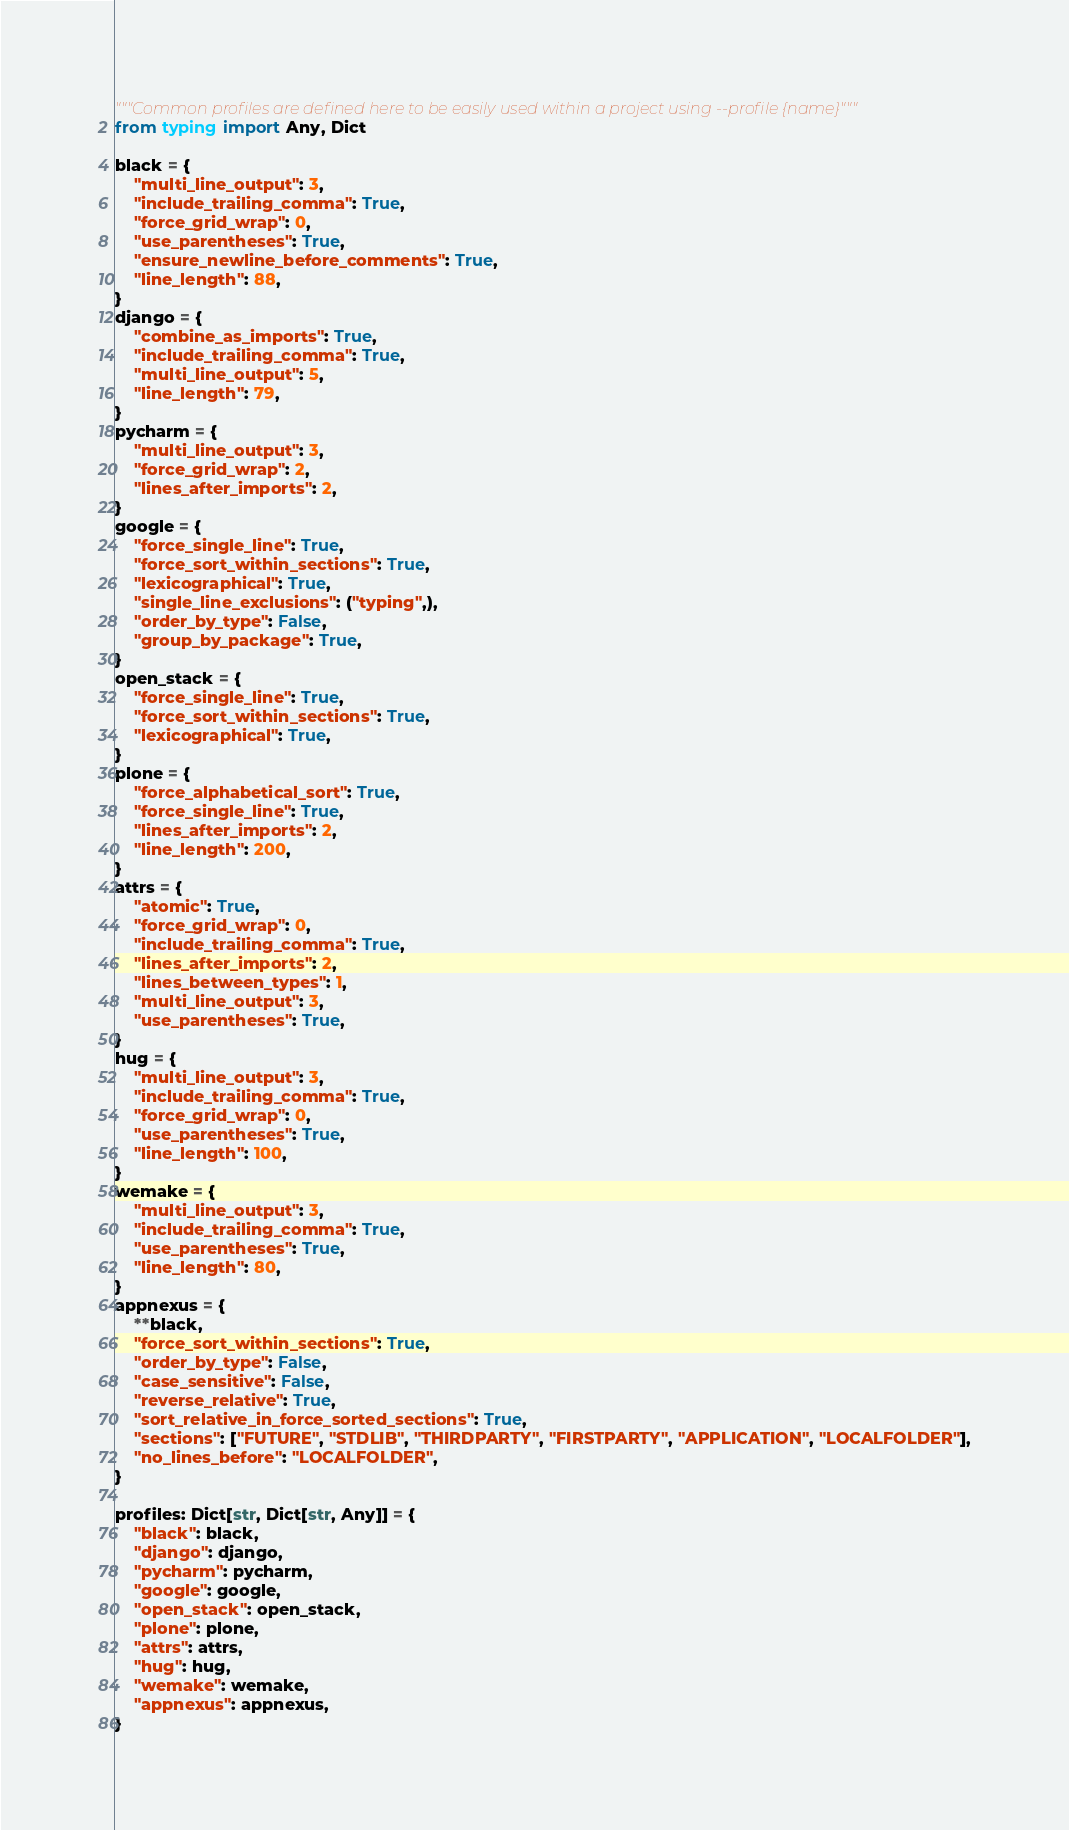Convert code to text. <code><loc_0><loc_0><loc_500><loc_500><_Python_>"""Common profiles are defined here to be easily used within a project using --profile {name}"""
from typing import Any, Dict

black = {
    "multi_line_output": 3,
    "include_trailing_comma": True,
    "force_grid_wrap": 0,
    "use_parentheses": True,
    "ensure_newline_before_comments": True,
    "line_length": 88,
}
django = {
    "combine_as_imports": True,
    "include_trailing_comma": True,
    "multi_line_output": 5,
    "line_length": 79,
}
pycharm = {
    "multi_line_output": 3,
    "force_grid_wrap": 2,
    "lines_after_imports": 2,
}
google = {
    "force_single_line": True,
    "force_sort_within_sections": True,
    "lexicographical": True,
    "single_line_exclusions": ("typing",),
    "order_by_type": False,
    "group_by_package": True,
}
open_stack = {
    "force_single_line": True,
    "force_sort_within_sections": True,
    "lexicographical": True,
}
plone = {
    "force_alphabetical_sort": True,
    "force_single_line": True,
    "lines_after_imports": 2,
    "line_length": 200,
}
attrs = {
    "atomic": True,
    "force_grid_wrap": 0,
    "include_trailing_comma": True,
    "lines_after_imports": 2,
    "lines_between_types": 1,
    "multi_line_output": 3,
    "use_parentheses": True,
}
hug = {
    "multi_line_output": 3,
    "include_trailing_comma": True,
    "force_grid_wrap": 0,
    "use_parentheses": True,
    "line_length": 100,
}
wemake = {
    "multi_line_output": 3,
    "include_trailing_comma": True,
    "use_parentheses": True,
    "line_length": 80,
}
appnexus = {
    **black,
    "force_sort_within_sections": True,
    "order_by_type": False,
    "case_sensitive": False,
    "reverse_relative": True,
    "sort_relative_in_force_sorted_sections": True,
    "sections": ["FUTURE", "STDLIB", "THIRDPARTY", "FIRSTPARTY", "APPLICATION", "LOCALFOLDER"],
    "no_lines_before": "LOCALFOLDER",
}

profiles: Dict[str, Dict[str, Any]] = {
    "black": black,
    "django": django,
    "pycharm": pycharm,
    "google": google,
    "open_stack": open_stack,
    "plone": plone,
    "attrs": attrs,
    "hug": hug,
    "wemake": wemake,
    "appnexus": appnexus,
}
</code> 